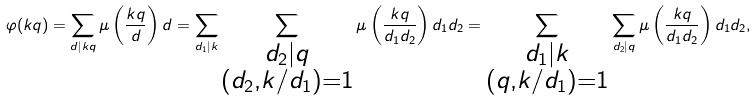Convert formula to latex. <formula><loc_0><loc_0><loc_500><loc_500>\varphi ( k q ) = \sum _ { d | k q } \mu \left ( \frac { k q } d \right ) d = \sum _ { d _ { 1 } | k } \sum _ { \substack { d _ { 2 } | q \\ ( d _ { 2 } , k / d _ { 1 } ) = 1 } } \mu \left ( \frac { k q } { d _ { 1 } d _ { 2 } } \right ) d _ { 1 } d _ { 2 } = \sum _ { \substack { d _ { 1 } | k \\ ( q , k / d _ { 1 } ) = 1 } } \sum _ { d _ { 2 } | q } \mu \left ( \frac { k q } { d _ { 1 } d _ { 2 } } \right ) d _ { 1 } d _ { 2 } ,</formula> 